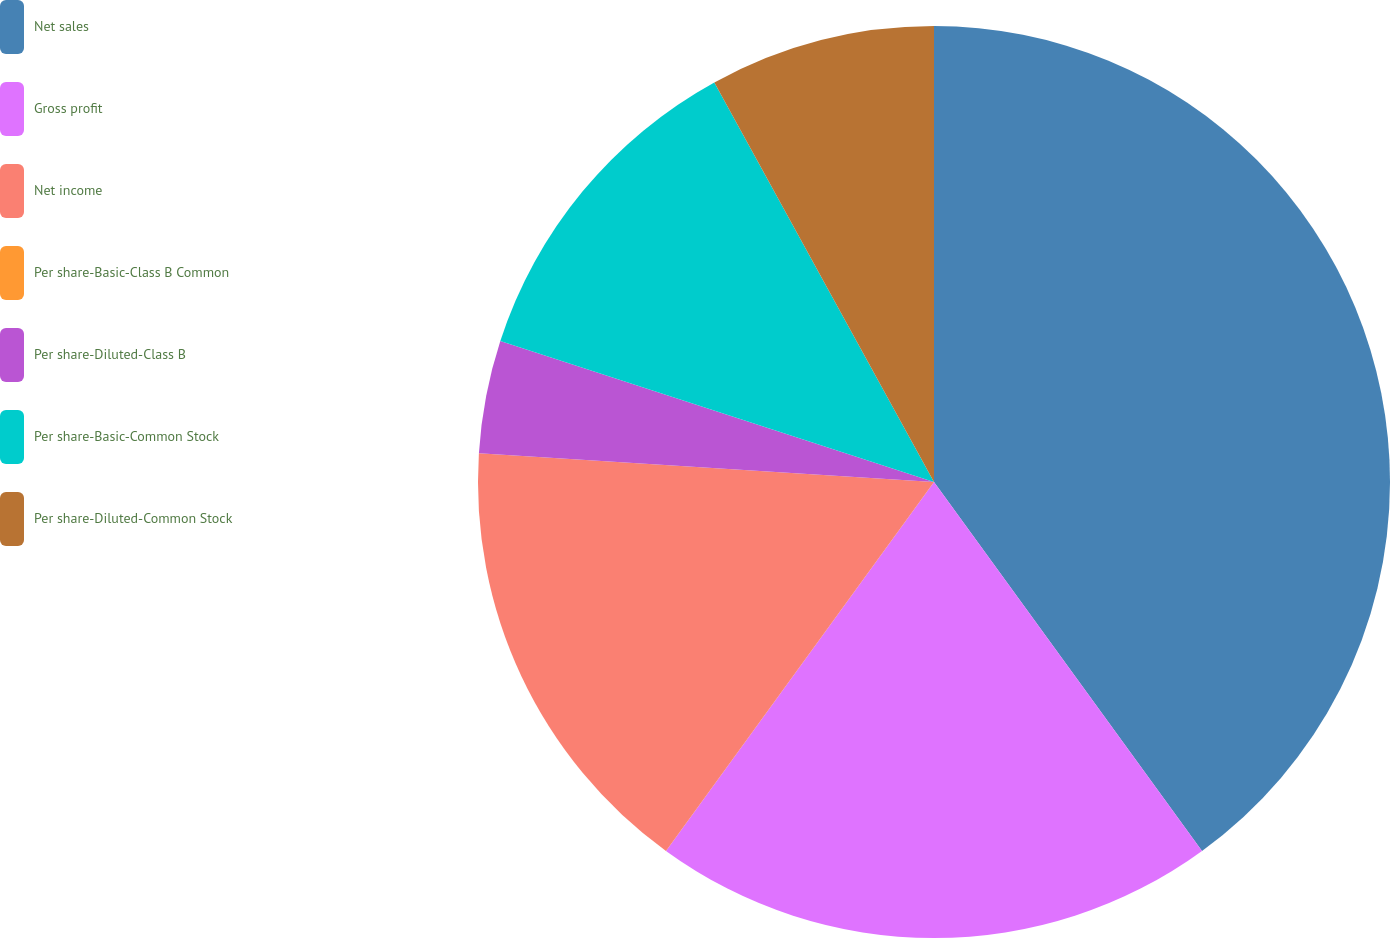Convert chart to OTSL. <chart><loc_0><loc_0><loc_500><loc_500><pie_chart><fcel>Net sales<fcel>Gross profit<fcel>Net income<fcel>Per share-Basic-Class B Common<fcel>Per share-Diluted-Class B<fcel>Per share-Basic-Common Stock<fcel>Per share-Diluted-Common Stock<nl><fcel>40.0%<fcel>20.0%<fcel>16.0%<fcel>0.0%<fcel>4.0%<fcel>12.0%<fcel>8.0%<nl></chart> 